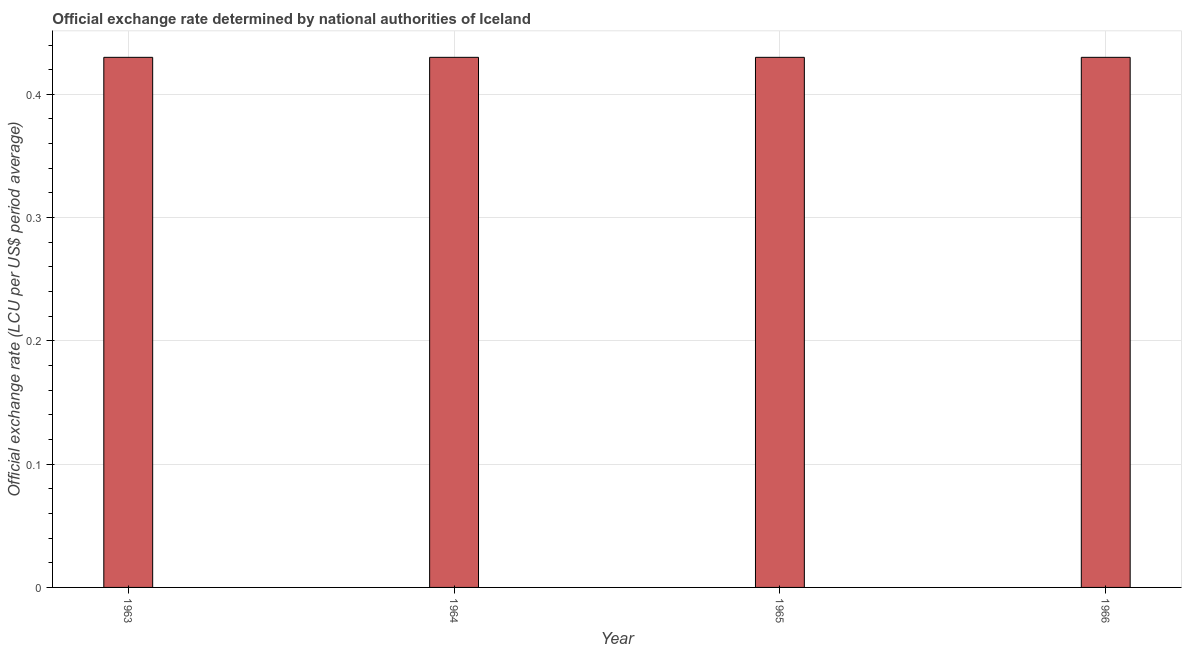What is the title of the graph?
Provide a succinct answer. Official exchange rate determined by national authorities of Iceland. What is the label or title of the X-axis?
Ensure brevity in your answer.  Year. What is the label or title of the Y-axis?
Offer a very short reply. Official exchange rate (LCU per US$ period average). What is the official exchange rate in 1966?
Offer a terse response. 0.43. Across all years, what is the maximum official exchange rate?
Offer a terse response. 0.43. Across all years, what is the minimum official exchange rate?
Your answer should be compact. 0.43. In which year was the official exchange rate maximum?
Give a very brief answer. 1963. What is the sum of the official exchange rate?
Ensure brevity in your answer.  1.72. What is the average official exchange rate per year?
Offer a terse response. 0.43. What is the median official exchange rate?
Provide a short and direct response. 0.43. What is the ratio of the official exchange rate in 1963 to that in 1965?
Your answer should be compact. 1. Is the difference between the official exchange rate in 1963 and 1966 greater than the difference between any two years?
Your answer should be very brief. Yes. What is the difference between the highest and the second highest official exchange rate?
Your response must be concise. 0. What is the difference between the highest and the lowest official exchange rate?
Ensure brevity in your answer.  0. How many bars are there?
Ensure brevity in your answer.  4. Are all the bars in the graph horizontal?
Give a very brief answer. No. What is the Official exchange rate (LCU per US$ period average) in 1963?
Provide a short and direct response. 0.43. What is the Official exchange rate (LCU per US$ period average) in 1964?
Offer a terse response. 0.43. What is the Official exchange rate (LCU per US$ period average) of 1965?
Offer a terse response. 0.43. What is the Official exchange rate (LCU per US$ period average) in 1966?
Give a very brief answer. 0.43. What is the difference between the Official exchange rate (LCU per US$ period average) in 1964 and 1966?
Keep it short and to the point. 0. What is the ratio of the Official exchange rate (LCU per US$ period average) in 1963 to that in 1964?
Offer a terse response. 1. What is the ratio of the Official exchange rate (LCU per US$ period average) in 1963 to that in 1965?
Offer a very short reply. 1. What is the ratio of the Official exchange rate (LCU per US$ period average) in 1964 to that in 1965?
Keep it short and to the point. 1. What is the ratio of the Official exchange rate (LCU per US$ period average) in 1964 to that in 1966?
Provide a short and direct response. 1. What is the ratio of the Official exchange rate (LCU per US$ period average) in 1965 to that in 1966?
Your response must be concise. 1. 